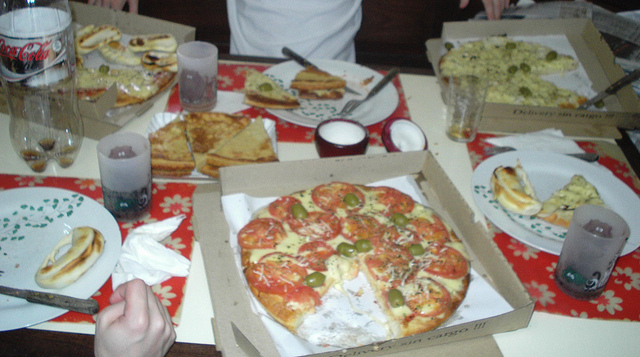<image>Which pizza is pepperoni? It is ambiguous which pizza is pepperoni. It might be the one in the middle or none at all. Which pizza is pepperoni? I am not sure which pizza is pepperoni. 